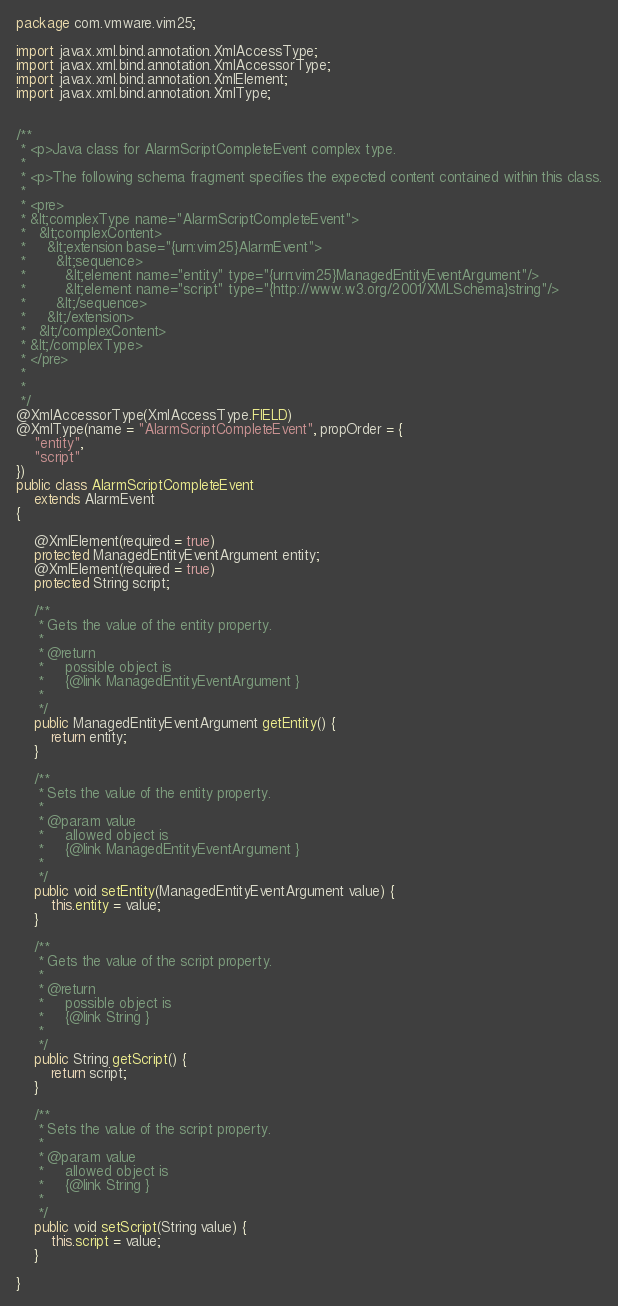<code> <loc_0><loc_0><loc_500><loc_500><_Java_>
package com.vmware.vim25;

import javax.xml.bind.annotation.XmlAccessType;
import javax.xml.bind.annotation.XmlAccessorType;
import javax.xml.bind.annotation.XmlElement;
import javax.xml.bind.annotation.XmlType;


/**
 * <p>Java class for AlarmScriptCompleteEvent complex type.
 * 
 * <p>The following schema fragment specifies the expected content contained within this class.
 * 
 * <pre>
 * &lt;complexType name="AlarmScriptCompleteEvent">
 *   &lt;complexContent>
 *     &lt;extension base="{urn:vim25}AlarmEvent">
 *       &lt;sequence>
 *         &lt;element name="entity" type="{urn:vim25}ManagedEntityEventArgument"/>
 *         &lt;element name="script" type="{http://www.w3.org/2001/XMLSchema}string"/>
 *       &lt;/sequence>
 *     &lt;/extension>
 *   &lt;/complexContent>
 * &lt;/complexType>
 * </pre>
 * 
 * 
 */
@XmlAccessorType(XmlAccessType.FIELD)
@XmlType(name = "AlarmScriptCompleteEvent", propOrder = {
    "entity",
    "script"
})
public class AlarmScriptCompleteEvent
    extends AlarmEvent
{

    @XmlElement(required = true)
    protected ManagedEntityEventArgument entity;
    @XmlElement(required = true)
    protected String script;

    /**
     * Gets the value of the entity property.
     * 
     * @return
     *     possible object is
     *     {@link ManagedEntityEventArgument }
     *     
     */
    public ManagedEntityEventArgument getEntity() {
        return entity;
    }

    /**
     * Sets the value of the entity property.
     * 
     * @param value
     *     allowed object is
     *     {@link ManagedEntityEventArgument }
     *     
     */
    public void setEntity(ManagedEntityEventArgument value) {
        this.entity = value;
    }

    /**
     * Gets the value of the script property.
     * 
     * @return
     *     possible object is
     *     {@link String }
     *     
     */
    public String getScript() {
        return script;
    }

    /**
     * Sets the value of the script property.
     * 
     * @param value
     *     allowed object is
     *     {@link String }
     *     
     */
    public void setScript(String value) {
        this.script = value;
    }

}
</code> 